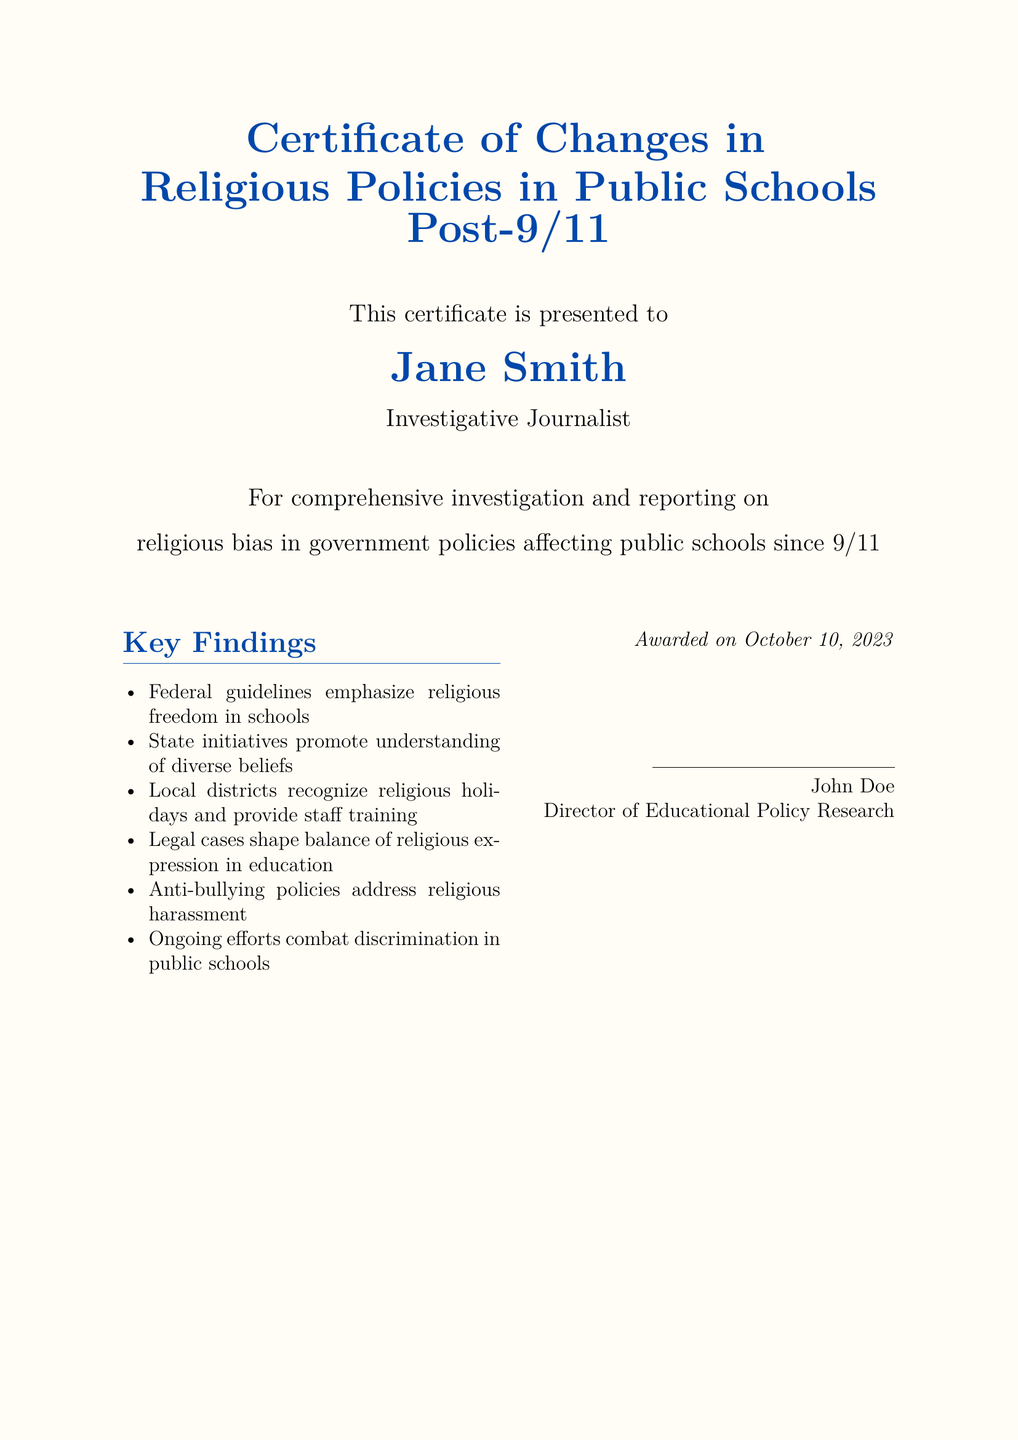What is the title of the certificate? The title of the certificate can be found at the top of the document, which states the focus of the certificate.
Answer: Certificate of Changes in Religious Policies in Public Schools Post-9/11 Who is the certificate presented to? The name of the individual receiving the certificate is explicitly mentioned in the document.
Answer: Jane Smith What is Jane Smith's occupation? The document indicates the professional title of the individual receiving the certificate.
Answer: Investigative Journalist When was the certificate awarded? The date of the award is specified at the bottom of the document.
Answer: October 10, 2023 How many key findings are listed in the certificate? The number of itemized key findings can be counted directly from the list in the document.
Answer: Six Who is the director of educational policy research? The person who signed the certificate and their position is indicated at the end of the document.
Answer: John Doe What is one of the federal guidelines mentioned in the key findings? A specific point from the "Key Findings" section highlights the emphasis of federal guidelines.
Answer: Religious freedom in schools What ongoing efforts are mentioned in the findings? The document mentions a continuous initiative aimed at addressing a specific issue in public schools.
Answer: Combat discrimination in public schools What type of policies address religious harassment? The document specifies a category of policies aimed at a particular issue related to religious bias.
Answer: Anti-bullying policies 